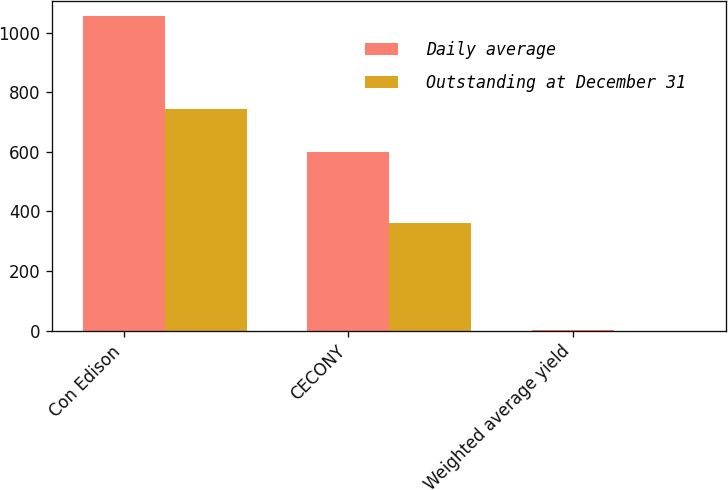Convert chart. <chart><loc_0><loc_0><loc_500><loc_500><stacked_bar_chart><ecel><fcel>Con Edison<fcel>CECONY<fcel>Weighted average yield<nl><fcel>Daily average<fcel>1054<fcel>600<fcel>1<nl><fcel>Outstanding at December 31<fcel>744<fcel>362<fcel>0.6<nl></chart> 